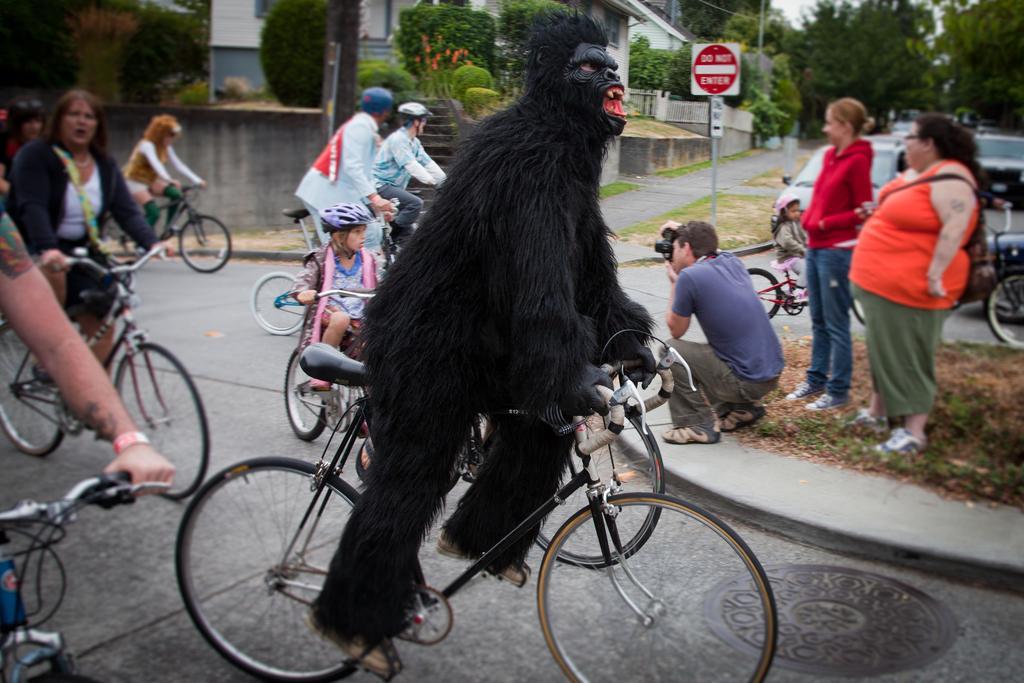Could you give a brief overview of what you see in this image? These persons are riding a bicycle. This girl is also riding a bicycle. We can able to see trees, plants and buildings. This man is in a squat position and taking snaps of this person's. 